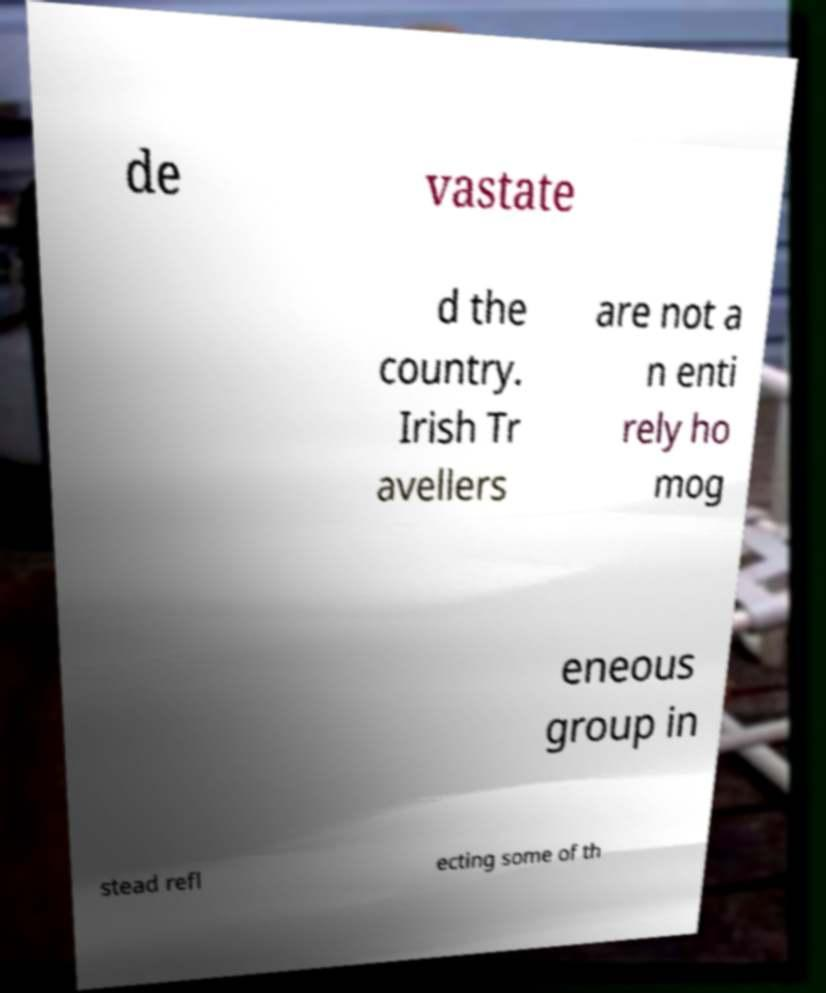Please read and relay the text visible in this image. What does it say? de vastate d the country. Irish Tr avellers are not a n enti rely ho mog eneous group in stead refl ecting some of th 